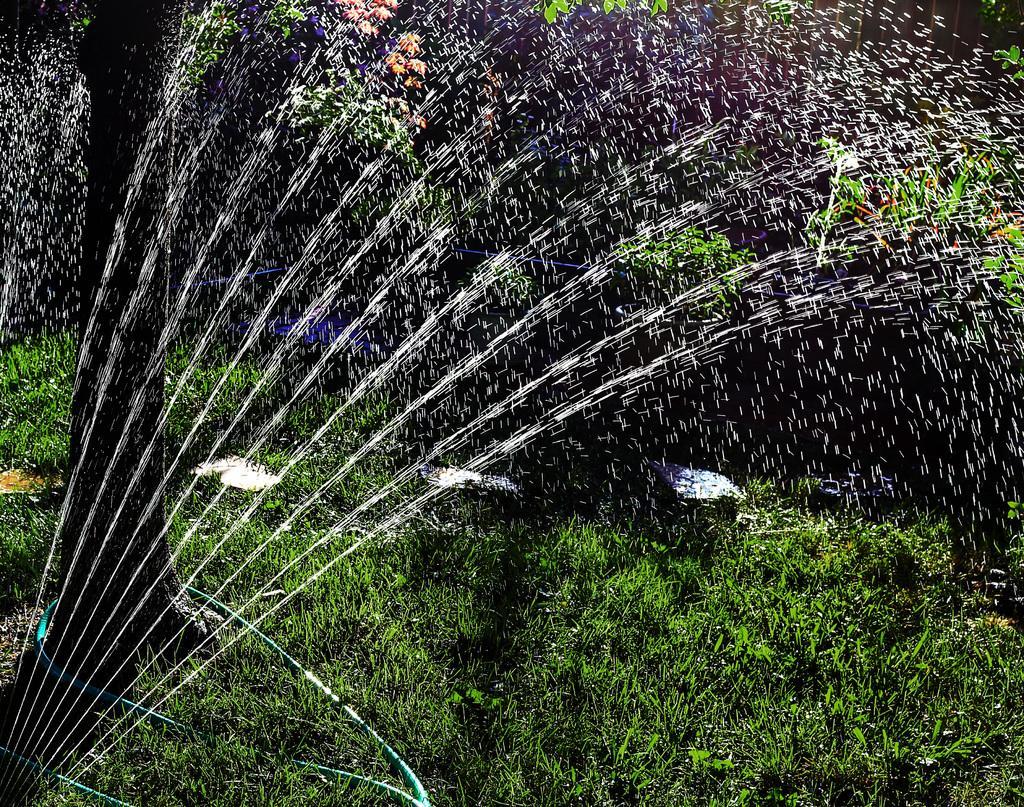How would you summarize this image in a sentence or two? In this picture we can see plants, grass, water and tree. 